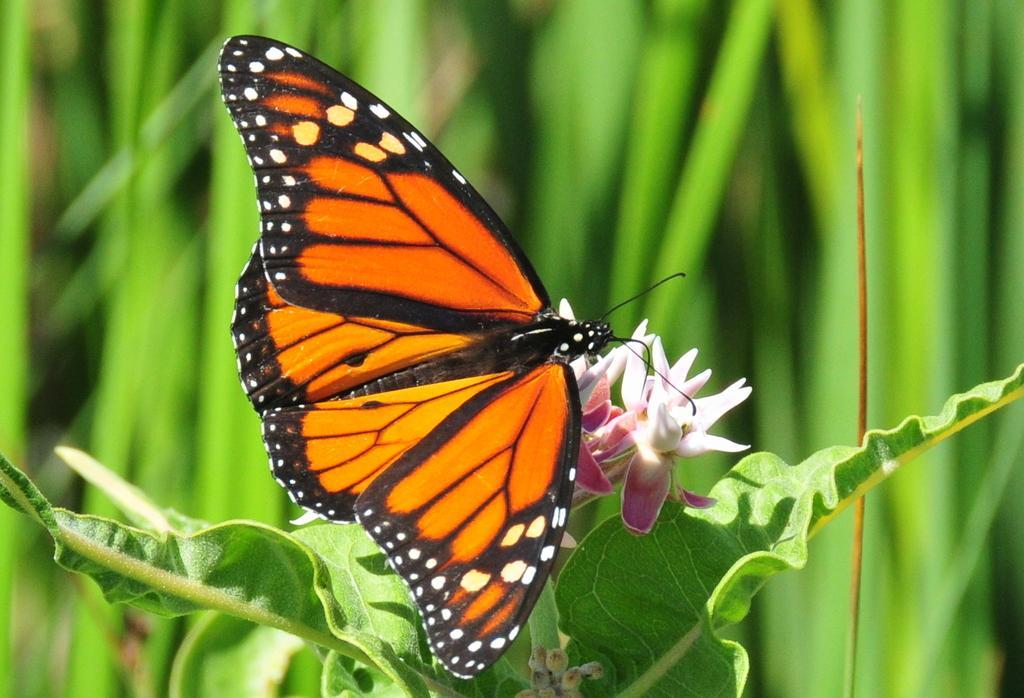Describe this image in one or two sentences. Background portion of the picture is in green color and its blur. In this picture we can see green leaves, butterfly, flowers and buds. 